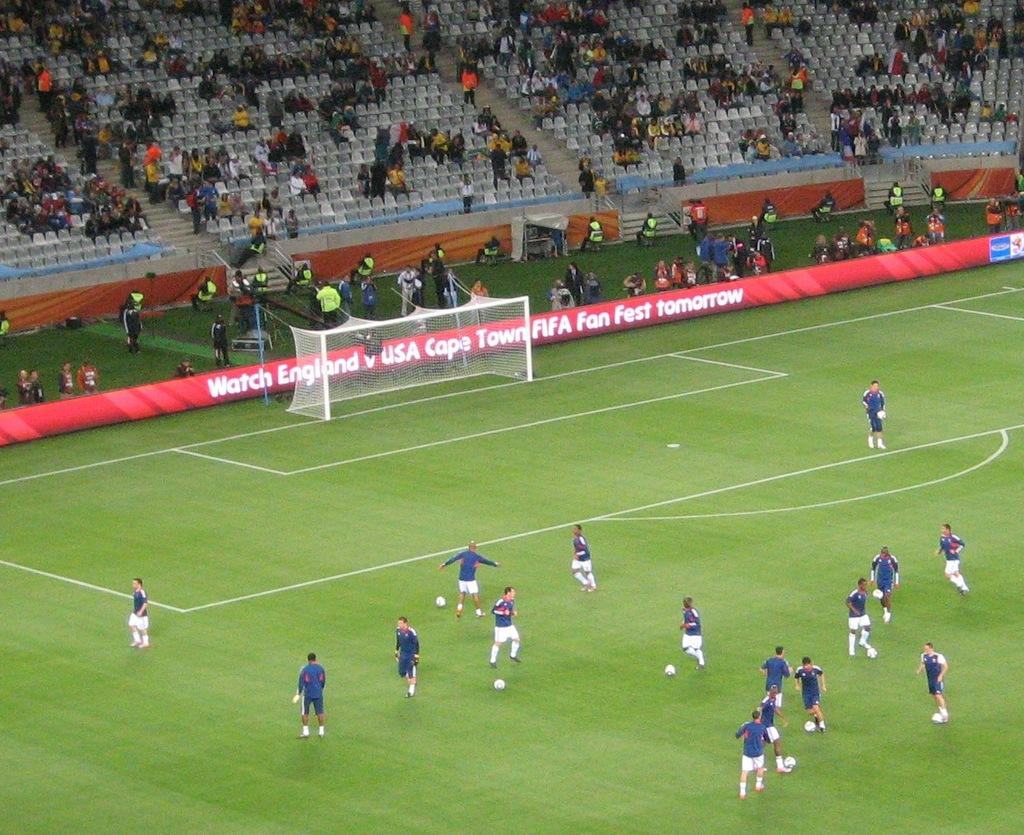Provide a one-sentence caption for the provided image. Soccer players practice on a field that is advertising tomorrow's game. 